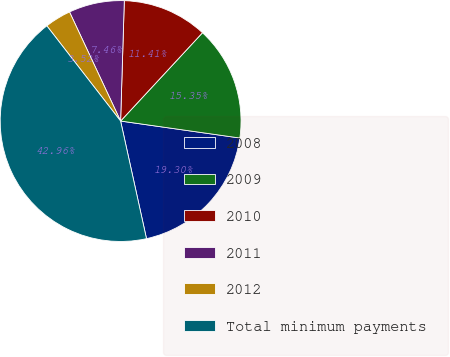Convert chart to OTSL. <chart><loc_0><loc_0><loc_500><loc_500><pie_chart><fcel>2008<fcel>2009<fcel>2010<fcel>2011<fcel>2012<fcel>Total minimum payments<nl><fcel>19.3%<fcel>15.35%<fcel>11.41%<fcel>7.46%<fcel>3.52%<fcel>42.96%<nl></chart> 